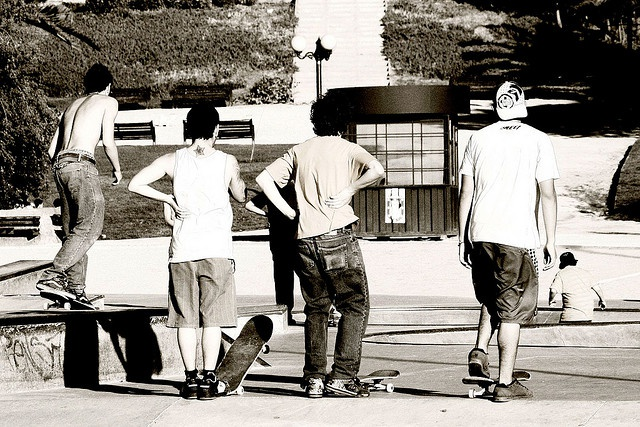Describe the objects in this image and their specific colors. I can see people in black, ivory, gray, and darkgray tones, people in black, white, darkgray, and gray tones, people in black, white, darkgray, and gray tones, people in black, white, darkgray, and gray tones, and people in black, white, gray, and darkgray tones in this image. 